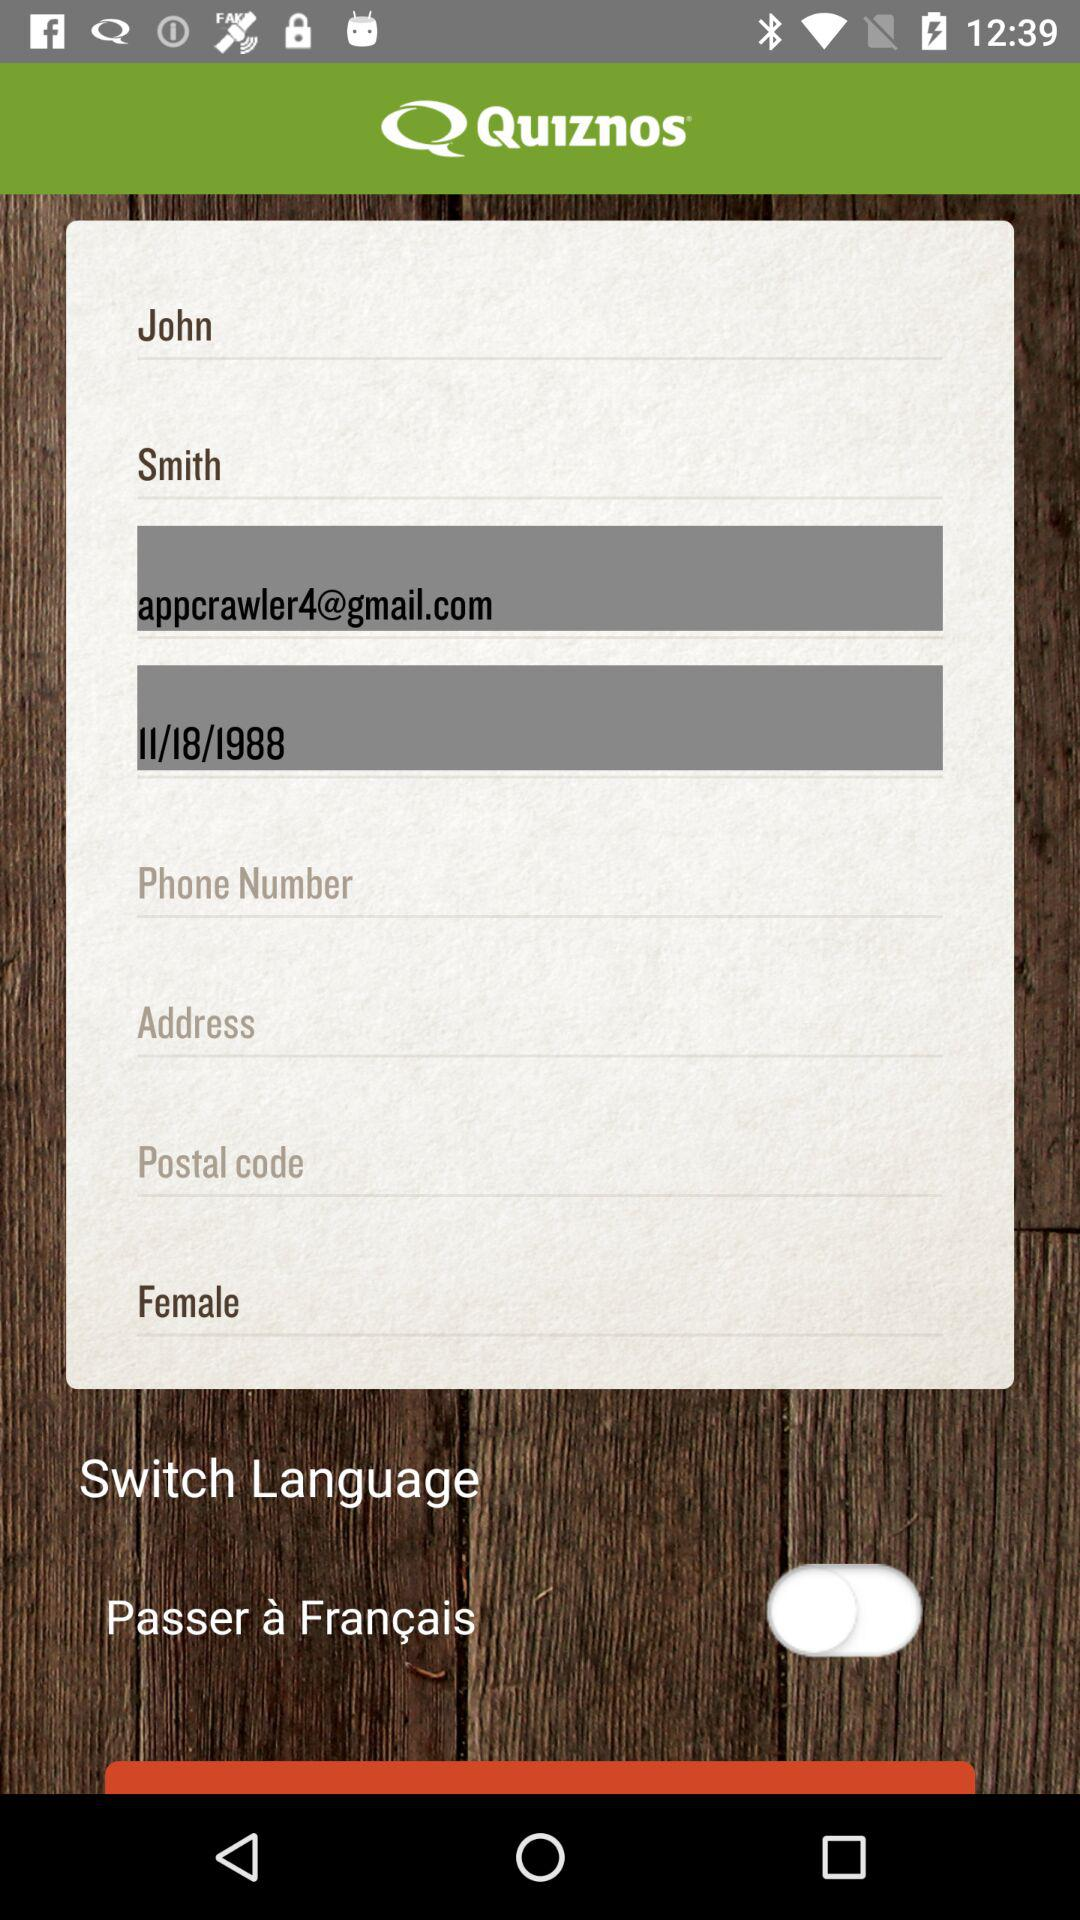What is the name of the application? The name of the application is "Quiznos". 